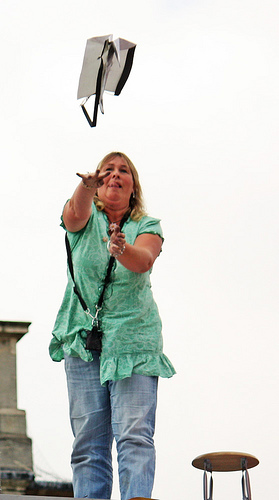<image>
Can you confirm if the bag thing is on the person? No. The bag thing is not positioned on the person. They may be near each other, but the bag thing is not supported by or resting on top of the person. 